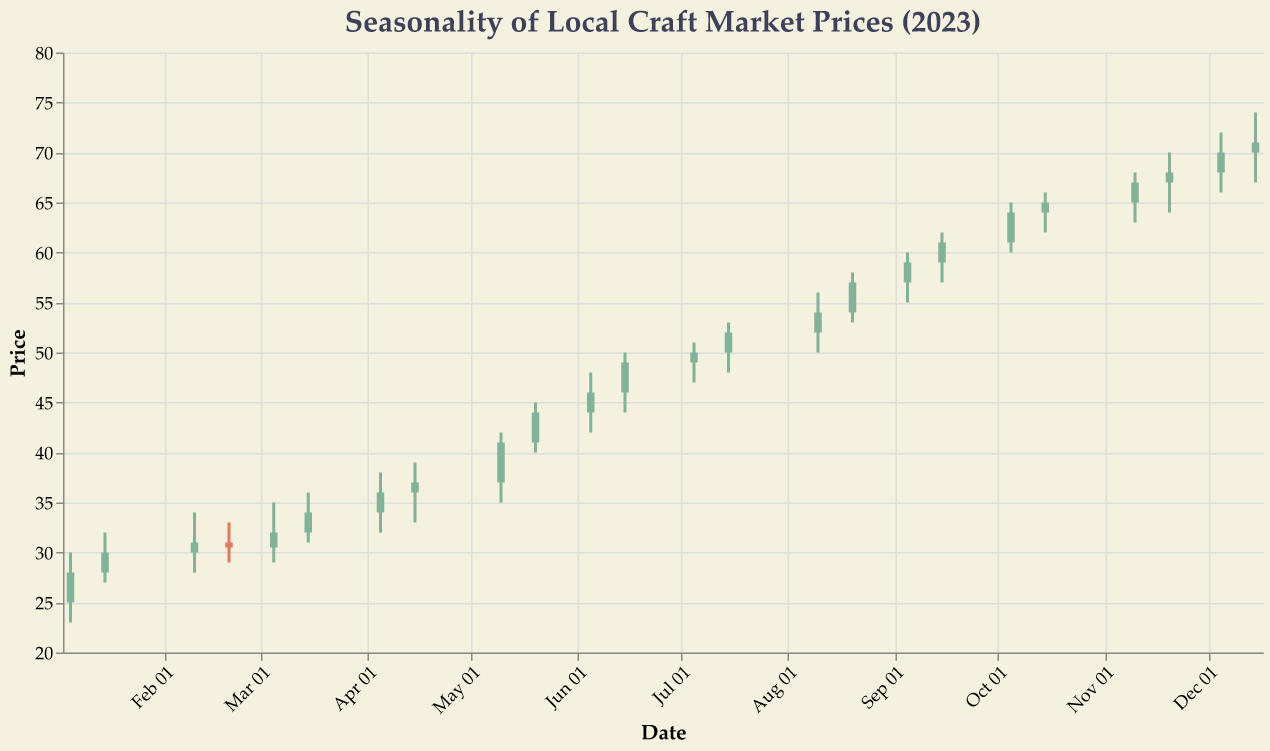How many data points are shown in the plot? Count the number of dates listed on the x-axis. Each candlestick represents one data point.
Answer: 24 What is the highest market price reached in the year? Locate the maximum point on the "High" column. The highest price is 74.00 on December 15, 2023.
Answer: 74.00 During which months did the local craft market prices show the most significant increase? Identify the months with the steepest upward trend by observing the closing prices. Notice the prices rise most significantly between January and June.
Answer: January to June How did the prices change between July and August? Compare the closing prices of July 15 (52.00) and August 20 (57.00). The price increased from 52.00 to 57.00.
Answer: Increased by 5.00 What is the difference between the opening prices on June 15 and December 15? Subtract the opening price on June 15 (46.00) from the opening price on December 15 (70.00). 70.00 - 46.00 = 24.00
Answer: 24.00 Which single month had the most significant price volatility? Identify the month with the largest range by subtracting the lowest price from the highest within the month. May had the largest range, with prices between 35.00 and 45.00.
Answer: May What was the closing price on November 20? Locate the candlestick for November 20 and note the value at the top of the candlestick body. The closing price is 68.00.
Answer: 68.00 Are there more green (increasing) or red (decreasing) candlesticks in the last quarter of the year? Observe the color of the candlesticks from October to December. Count the green (increasing) candlesticks. There are 6 candlesticks in total, with 4 green, indicating increasing prices.
Answer: More green candlesticks Describe the general trend in craft market prices throughout the year. Consider the overall pattern from January to December. The trend appears to be generally upward, with prices increasing from around 25.00 to 71.00 over the year.
Answer: Upward trend 